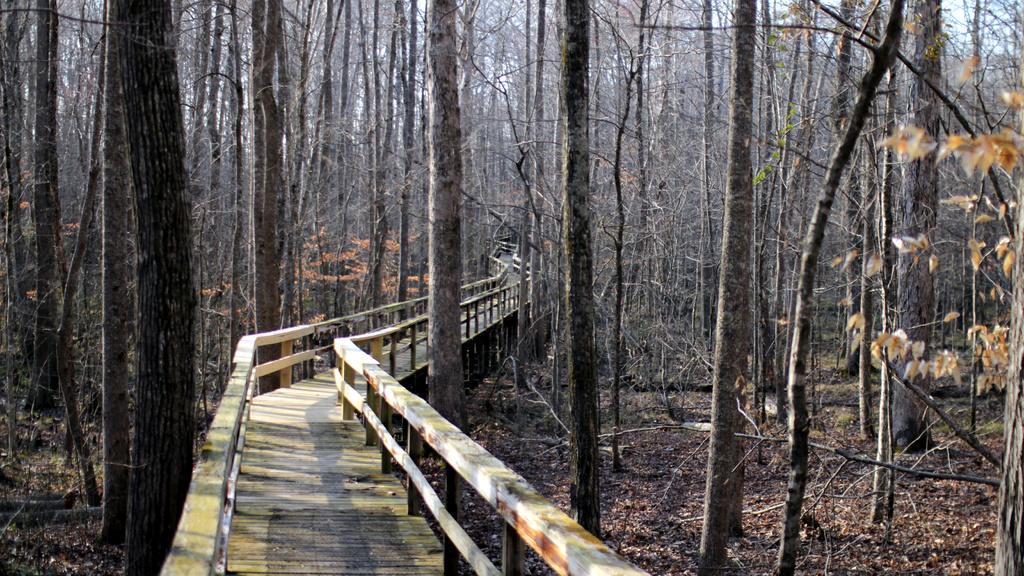Please provide a concise description of this image. In the picture there is a wooden walkway in between the forest, there are a lot of dry trees around the walkway. 